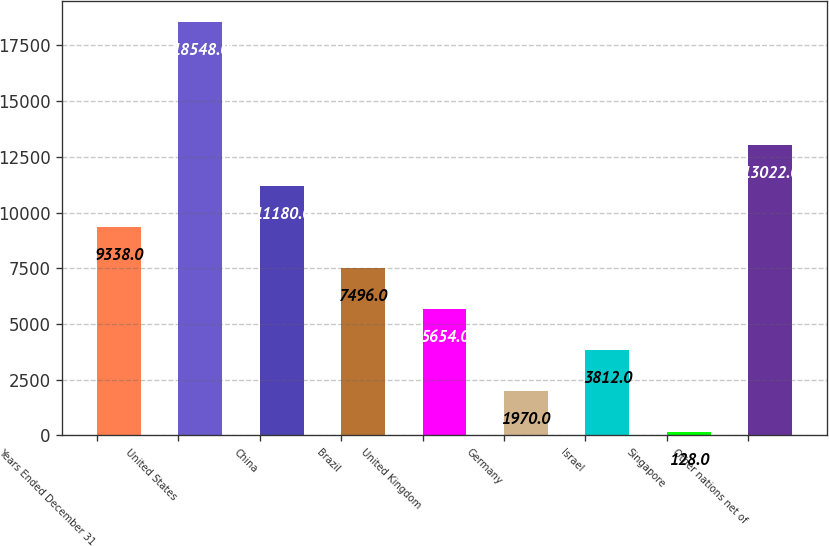Convert chart. <chart><loc_0><loc_0><loc_500><loc_500><bar_chart><fcel>Years Ended December 31<fcel>United States<fcel>China<fcel>Brazil<fcel>United Kingdom<fcel>Germany<fcel>Israel<fcel>Singapore<fcel>Other nations net of<nl><fcel>9338<fcel>18548<fcel>11180<fcel>7496<fcel>5654<fcel>1970<fcel>3812<fcel>128<fcel>13022<nl></chart> 